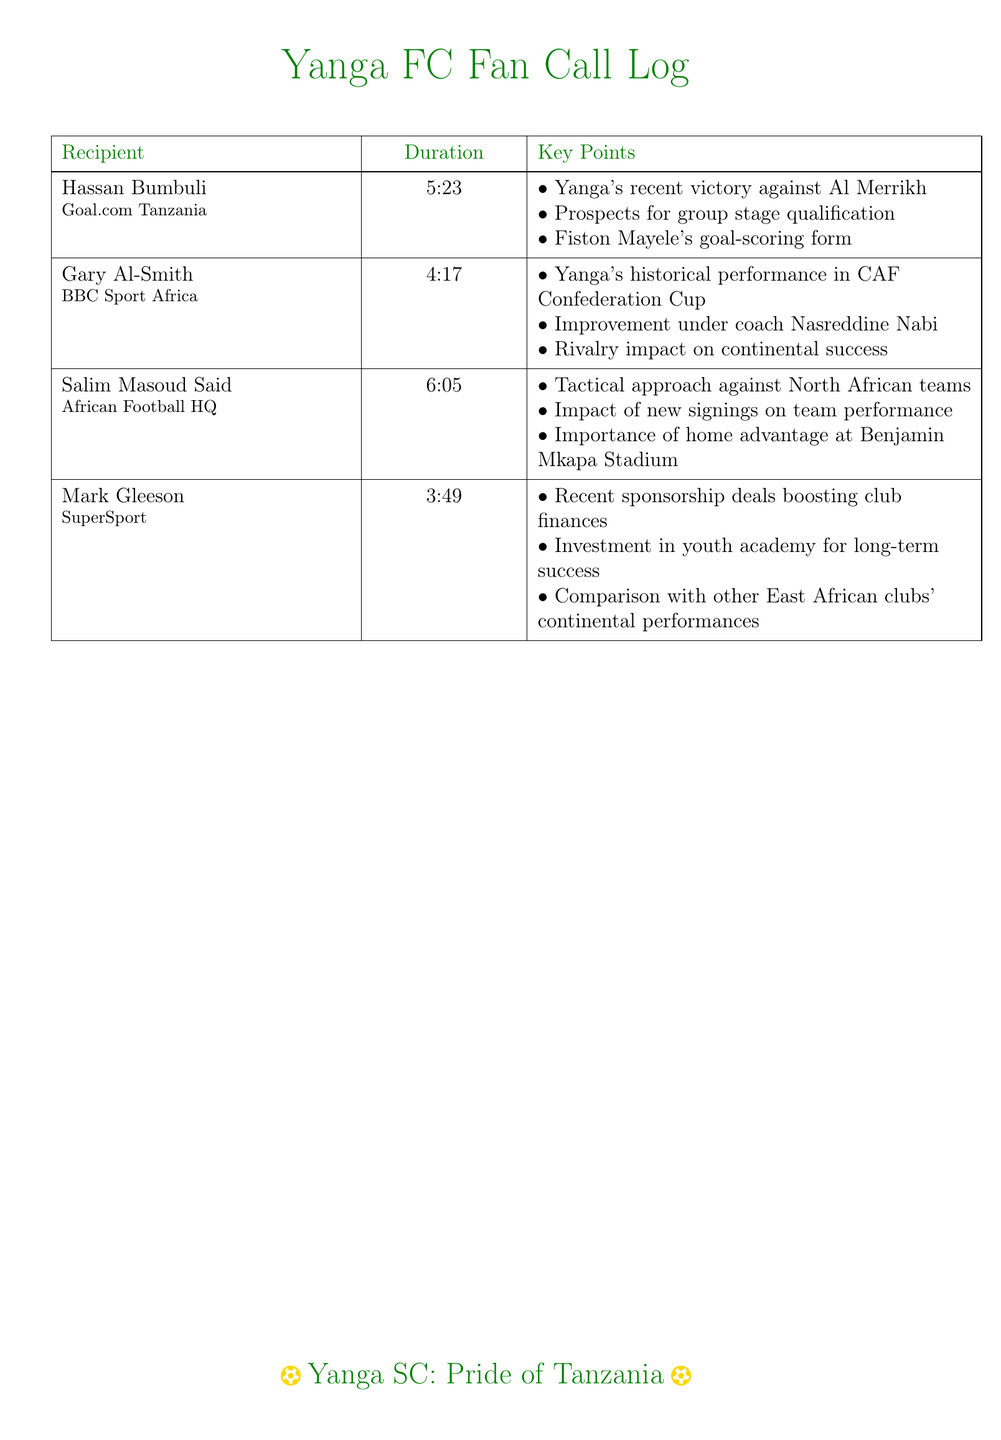What is the duration of the call with Hassan Bumbuli? The duration is clearly listed in the table next to his name.
Answer: 5:23 Who is the journalist from BBC Sport Africa? The document identifies the journalist affiliated with BBC Sport Africa.
Answer: Gary Al-Smith What was a key point discussed with Salim Masoud Said? The document lists key points under each journalist, and one of them for Salim Masoud Said is noted.
Answer: Tactical approach against North African teams How long was the call with Mark Gleeson? The duration of Mark Gleeson's call is specified in the document.
Answer: 3:49 What is one impact mentioned regarding Yanga's performance? The document provides insights into various impacts mentioned during the calls.
Answer: Improvement under coach Nasreddine Nabi What is the focus of the call with Gary Al-Smith? The document lists the topics of discussion in the call with this journalist.
Answer: Historical performance in CAF Confederation Cup Which club's performance is compared with Yanga's in the document? The document mentions other clubs in the East African context regarding continental performances.
Answer: Other East African clubs What is a factor that enhances Yanga's performance at home? The key points include specific advantages for Yanga during home games.
Answer: Importance of home advantage at Benjamin Mkapa Stadium 